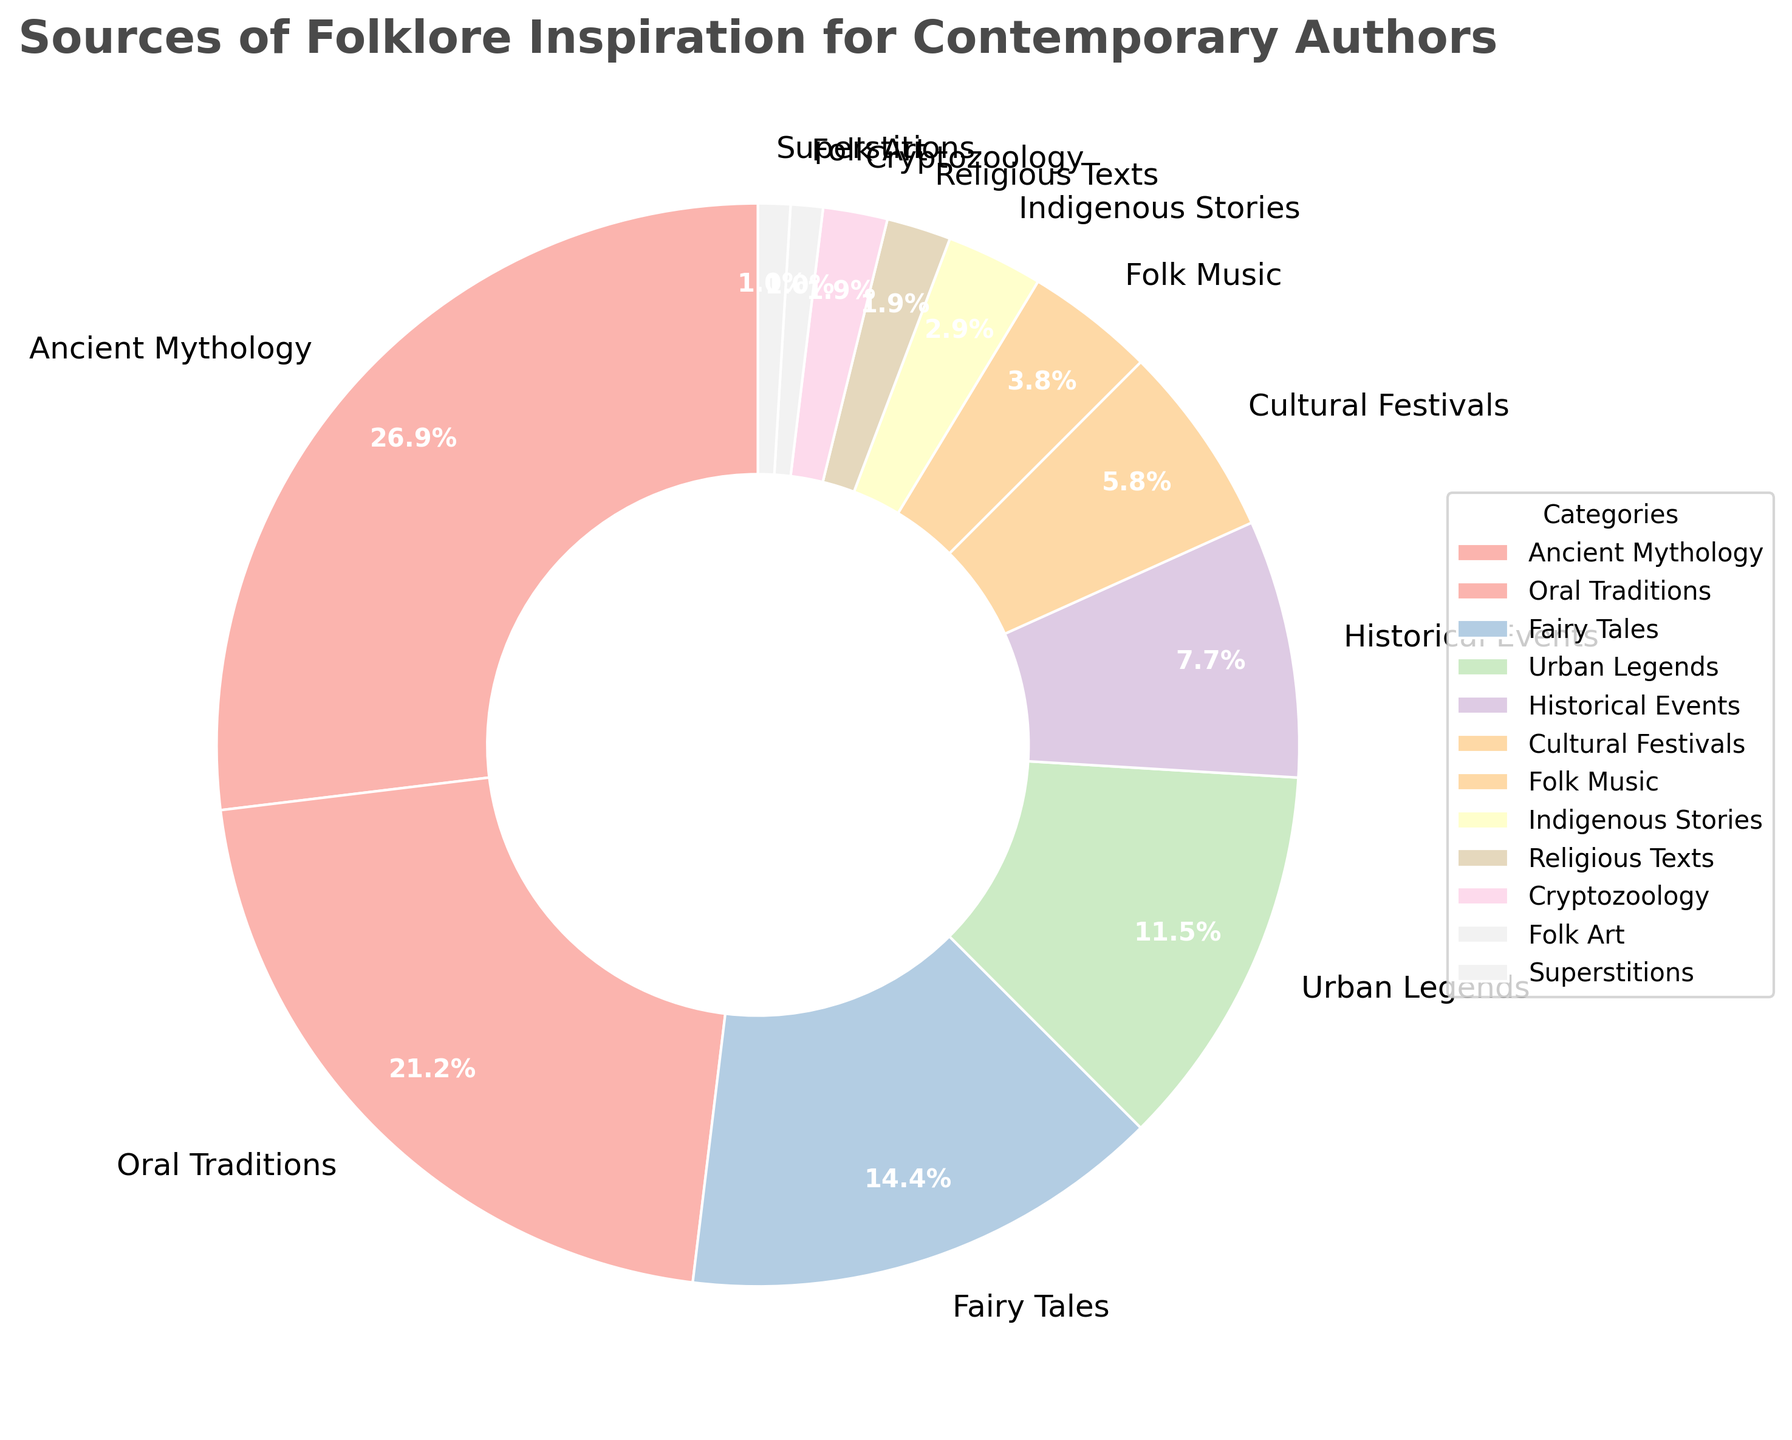What category has the highest percentage of inspiration sources for contemporary authors? The pie chart shows that "Ancient Mythology" has the largest segment with 28% of the sources.
Answer: Ancient Mythology Which two categories combined make up the majority of the folklore inspiration sources? "Ancient Mythology" has 28% and "Oral Traditions" have 22%. Together, they account for 50%, which sums up to more than half.
Answer: Ancient Mythology and Oral Traditions What is the difference in percentage between Urban Legends and Fairy Tales? The percentage for Urban Legends is 12% and for Fairy Tales is 15%. The difference is 15% - 12% = 3%.
Answer: 3% If you combine the percentages of sources related to "Cultural Festivals," "Folk Music," and "Indigenous Stories," what do you get? "Cultural Festivals" has 6%, "Folk Music" has 4%, and "Indigenous Stories" has 3%. Adding them yields 6% + 4% + 3% = 13%.
Answer: 13% How many categories contribute 2% or less in inspiration sources? The categories with 2% or less are "Religious Texts," "Cryptozoology," "Folk Art," and "Superstitions," totaling 4 categories.
Answer: 4 Which category, between Urban Legends and Historical Events, is less significant according to the chart? Historical Events have 8%, while Urban Legends have 12%. Therefore, Historical Events are less significant.
Answer: Historical Events What percentage of the pie chart does the combination of the smallest three segments represent? The smallest three segments are "Folk Art," "Superstitions," and "Religious Texts," each with 1% and 2% respectively. Adding them gives 1% + 1% + 2% = 4%.
Answer: 4% Which category has the lowest percentage of folklore inspiration sources? The pie chart shows that "Folk Art" and "Superstitions" are tied for the lowest, each with 1%.
Answer: Folk Art and Superstitions If you were to remove the top three most significant categories, what percentage of inspiration sources would remain? The top three categories are "Ancient Mythology" (28%), "Oral Traditions" (22%), and "Fairy Tales" (15%). Adding them gives 28% + 22% + 15% = 65%. The remaining percentage is 100% - 65% = 35%.
Answer: 35% 